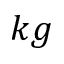Convert formula to latex. <formula><loc_0><loc_0><loc_500><loc_500>k g</formula> 